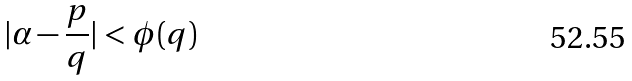<formula> <loc_0><loc_0><loc_500><loc_500>| \alpha - \frac { p } { q } | < \phi ( q )</formula> 